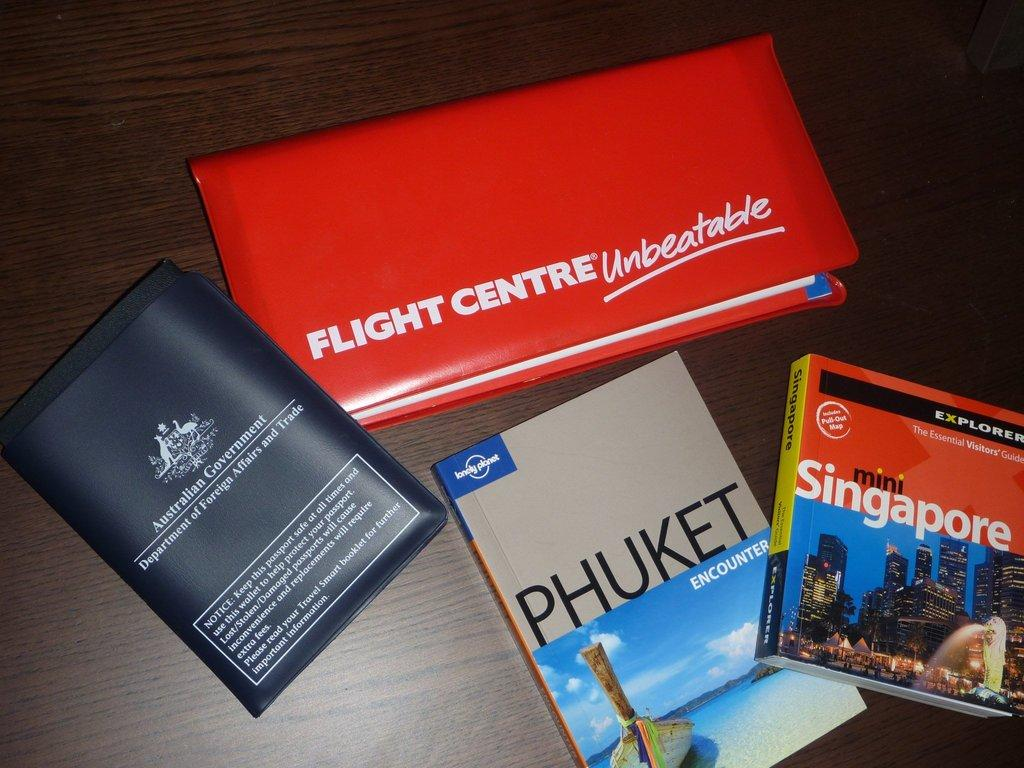<image>
Relay a brief, clear account of the picture shown. Two travel books called Mini Singapore and Phuket Encounter are on a table by two pouches. 